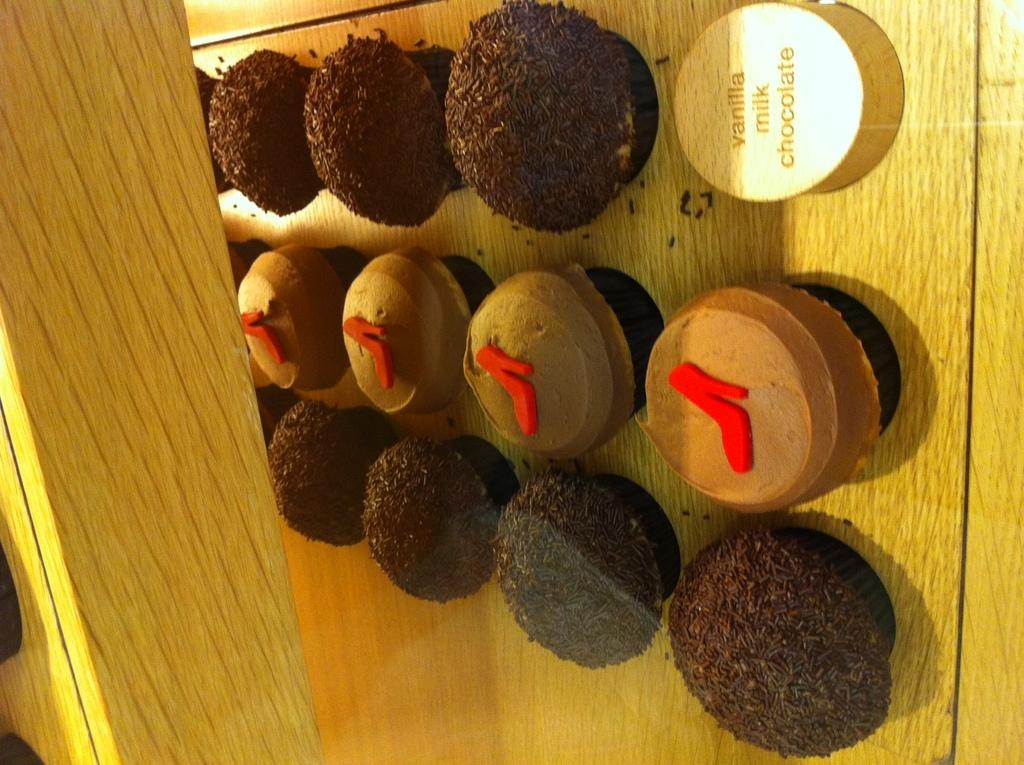What type of dessert can be seen in the foreground of the image? There are cupcakes in the foreground of the image. What is the cupcakes resting on? The cupcakes are on a wooden surface. Can you describe the material visible on the left side of the image? There is wood visible on the left side of the image. Where is the toy bear playing with the kettle in the image? There is no toy bear or kettle present in the image. 